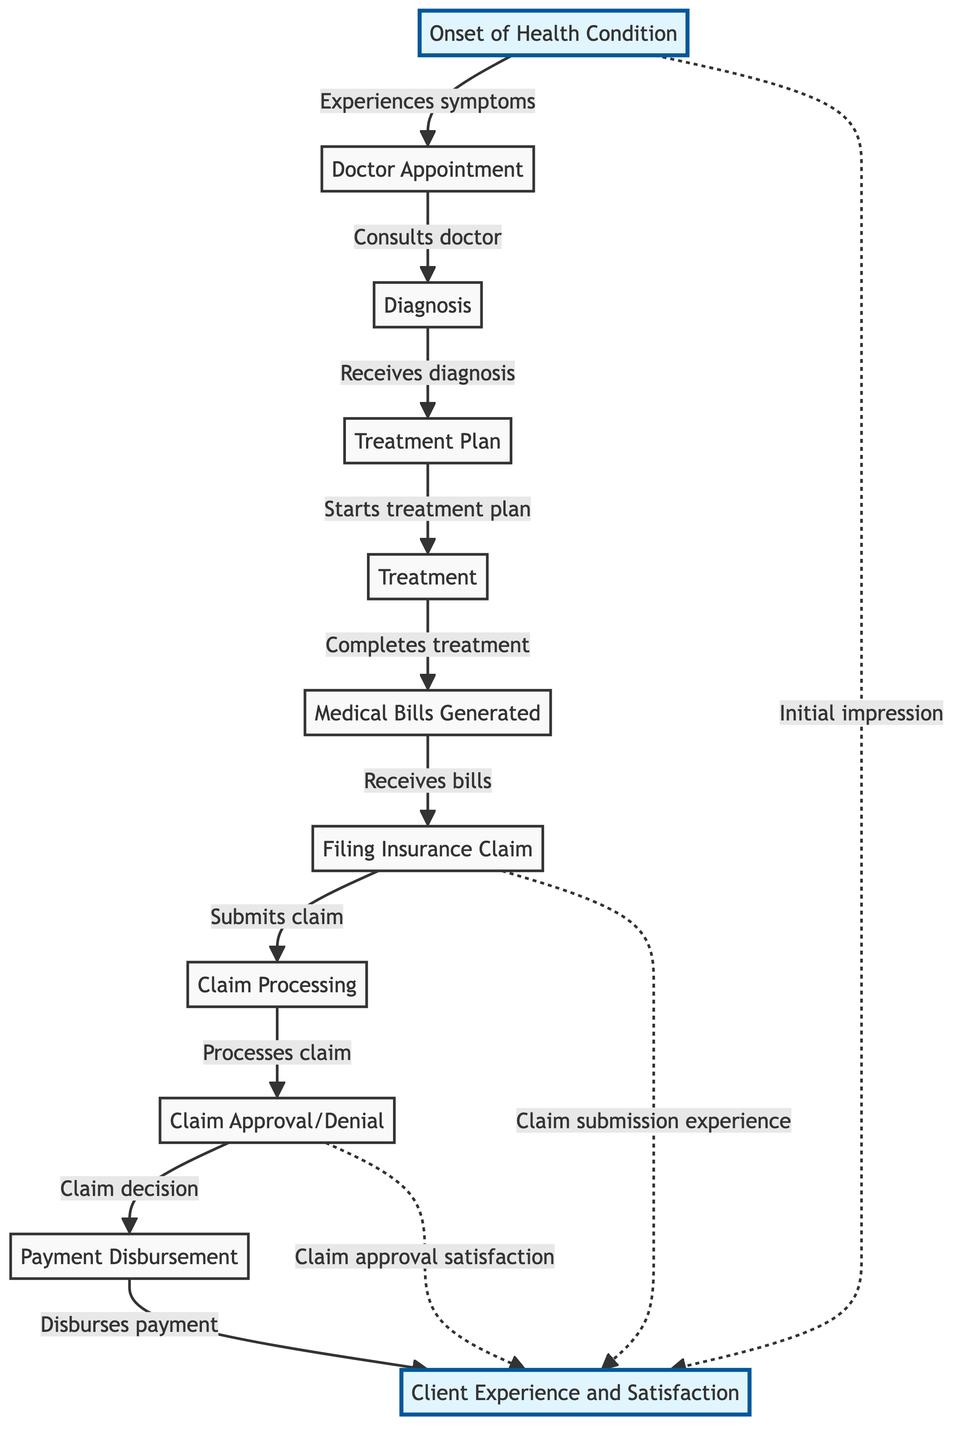What is the first step in the lifecycle of an insurance claim? The first step in the diagram is "Onset of Health Condition," which indicates the starting point of the process.
Answer: Onset of Health Condition How many stages are there in the explicit claim processing flow? By counting the steps between filing the insurance claim and client experience, we see 5 distinct stages: claim processing, claim approval, and payment disbursement.
Answer: 5 What leads to the generation of medical bills? The medical bills are generated after the completion of treatment, as indicated by the directed edge from treatment to bills generated.
Answer: Treatment What impact does the claim approval have on client experience? Claim approval relates to client experience through a directed edge labelled "Claim approval satisfaction," indicating that the approval decision significantly affects client satisfaction.
Answer: Claim approval satisfaction What action follows after receiving the medical bills? After receiving the bills, the next action taken is to file an insurance claim, as shown by the arrow connecting these two nodes in the diagram.
Answer: Filing Insurance Claim Which nodes directly impact client experience? The nodes highlighted in the diagram that affect client experience include the "Onset of Health Condition," "Insurance Claim," and "Claim Approval." Each of these nodes has a directed edge connecting them to the client experience.
Answer: Onset of Health Condition, Insurance Claim, Claim Approval What is represented by the dashed lines in the diagram? The dashed lines illustrate indirect influences on client experience, such as initial impressions and the claim submission experience, highlighting the subtler aspects of client satisfaction.
Answer: Initial impression, Claim submission experience What occurs just after the "Diagnosis" stage? The process after "Diagnosis" moves to the "Treatment Plan" stage, indicating that a diagnosis leads directly to creating a treatment plan.
Answer: Treatment Plan 